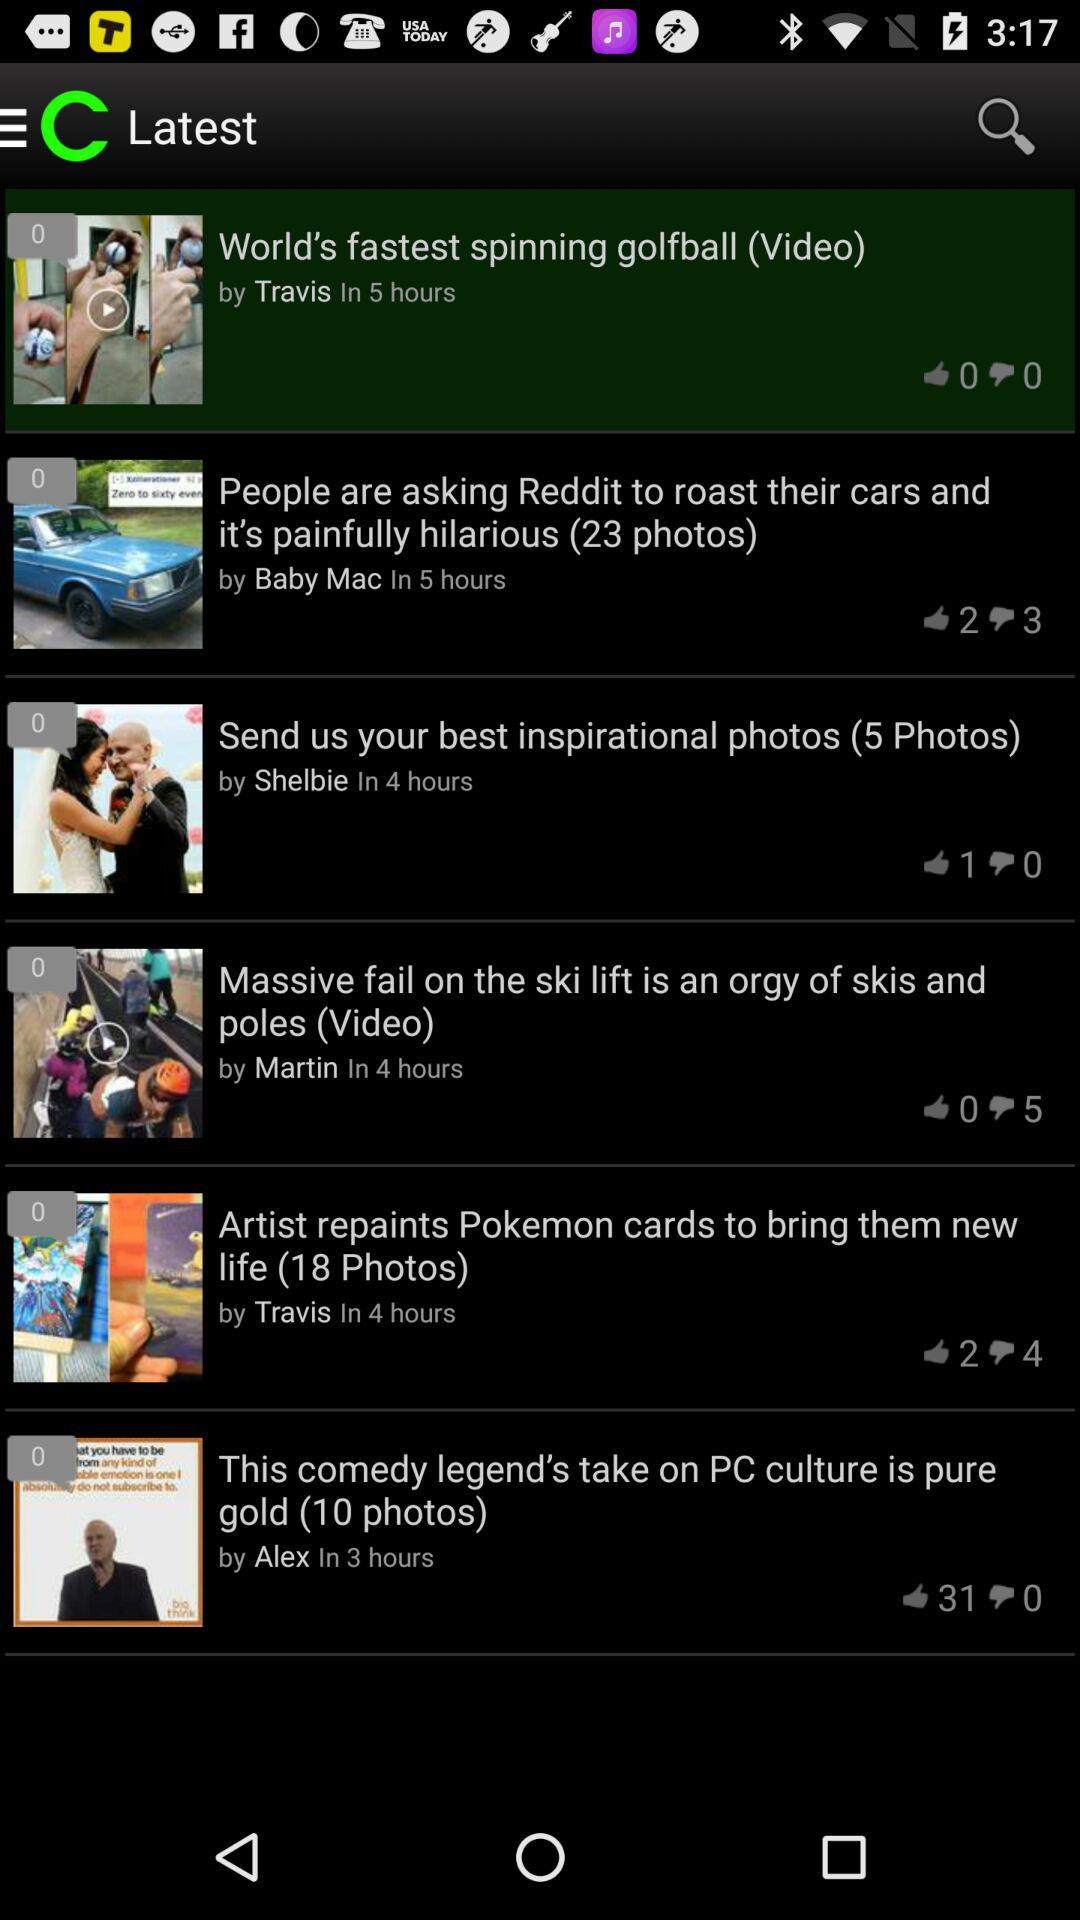When was the "World's fastest spinning golfball (Video)" posted? The "World's fastest spinning golfball (Video)" was posted 5 hours ago. 